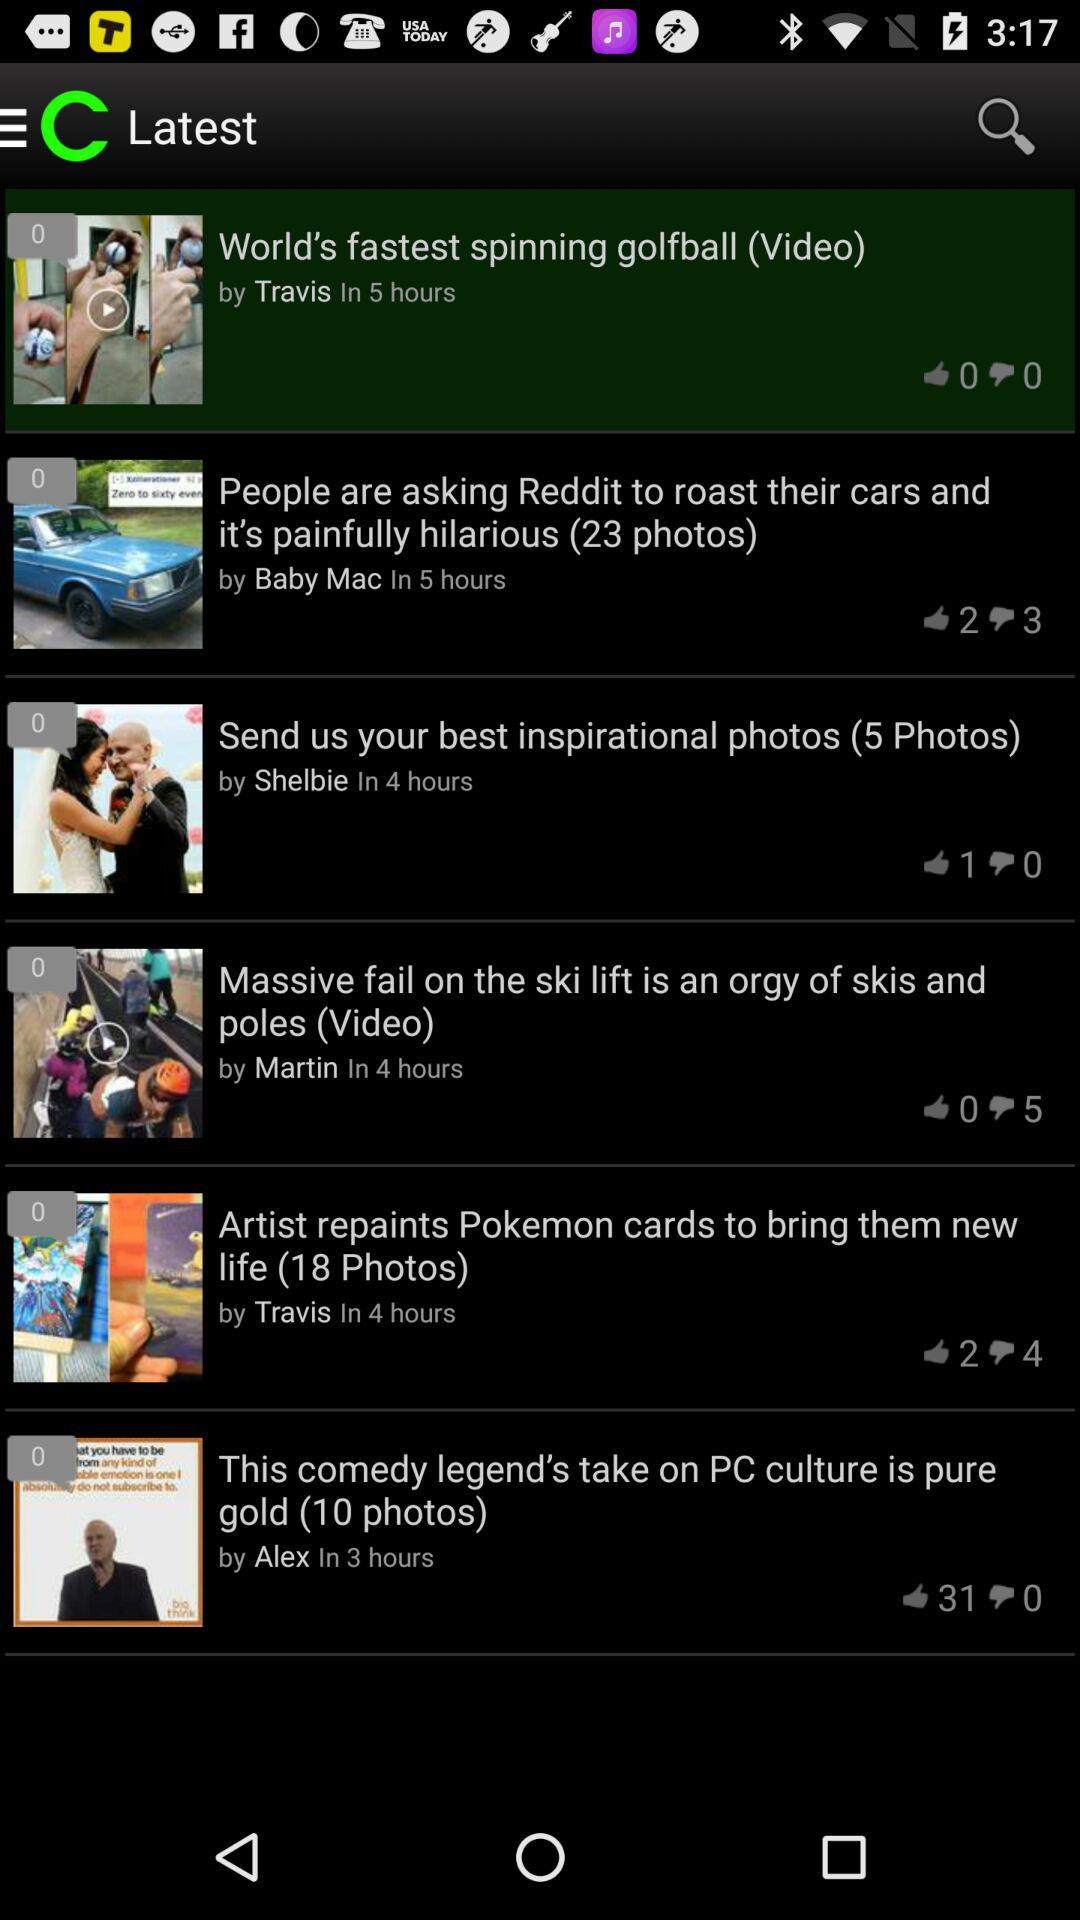When was the "World's fastest spinning golfball (Video)" posted? The "World's fastest spinning golfball (Video)" was posted 5 hours ago. 